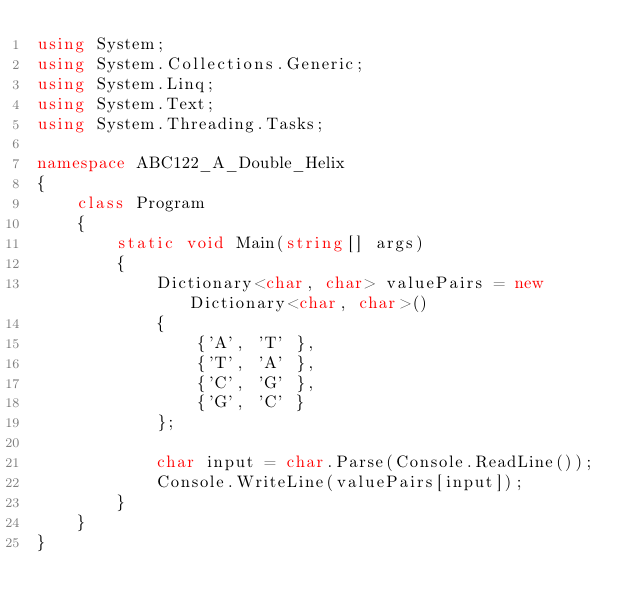<code> <loc_0><loc_0><loc_500><loc_500><_C#_>using System;
using System.Collections.Generic;
using System.Linq;
using System.Text;
using System.Threading.Tasks;

namespace ABC122_A_Double_Helix
{
	class Program
	{
		static void Main(string[] args)
		{
			Dictionary<char, char> valuePairs = new Dictionary<char, char>()
			{
				{'A', 'T' },
				{'T', 'A' },
				{'C', 'G' },
				{'G', 'C' }
			};

			char input = char.Parse(Console.ReadLine());
			Console.WriteLine(valuePairs[input]);
		}
	}
}
</code> 